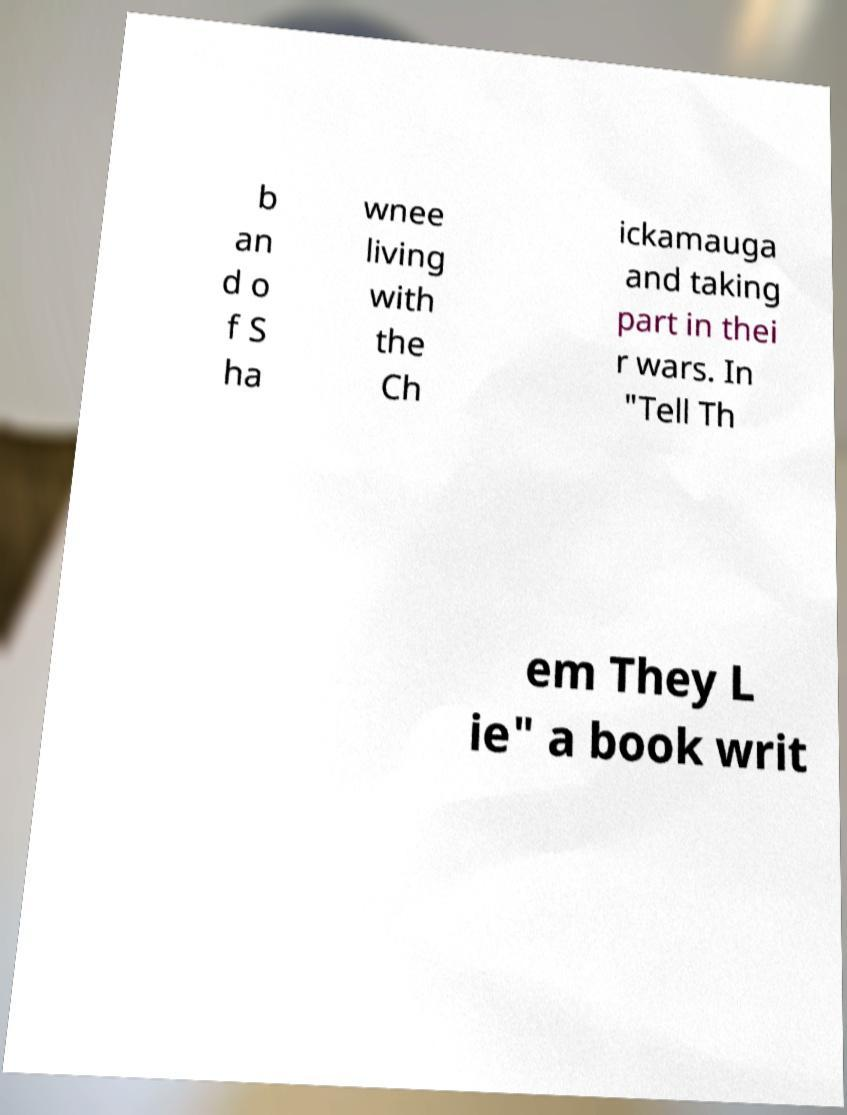There's text embedded in this image that I need extracted. Can you transcribe it verbatim? b an d o f S ha wnee living with the Ch ickamauga and taking part in thei r wars. In "Tell Th em They L ie" a book writ 